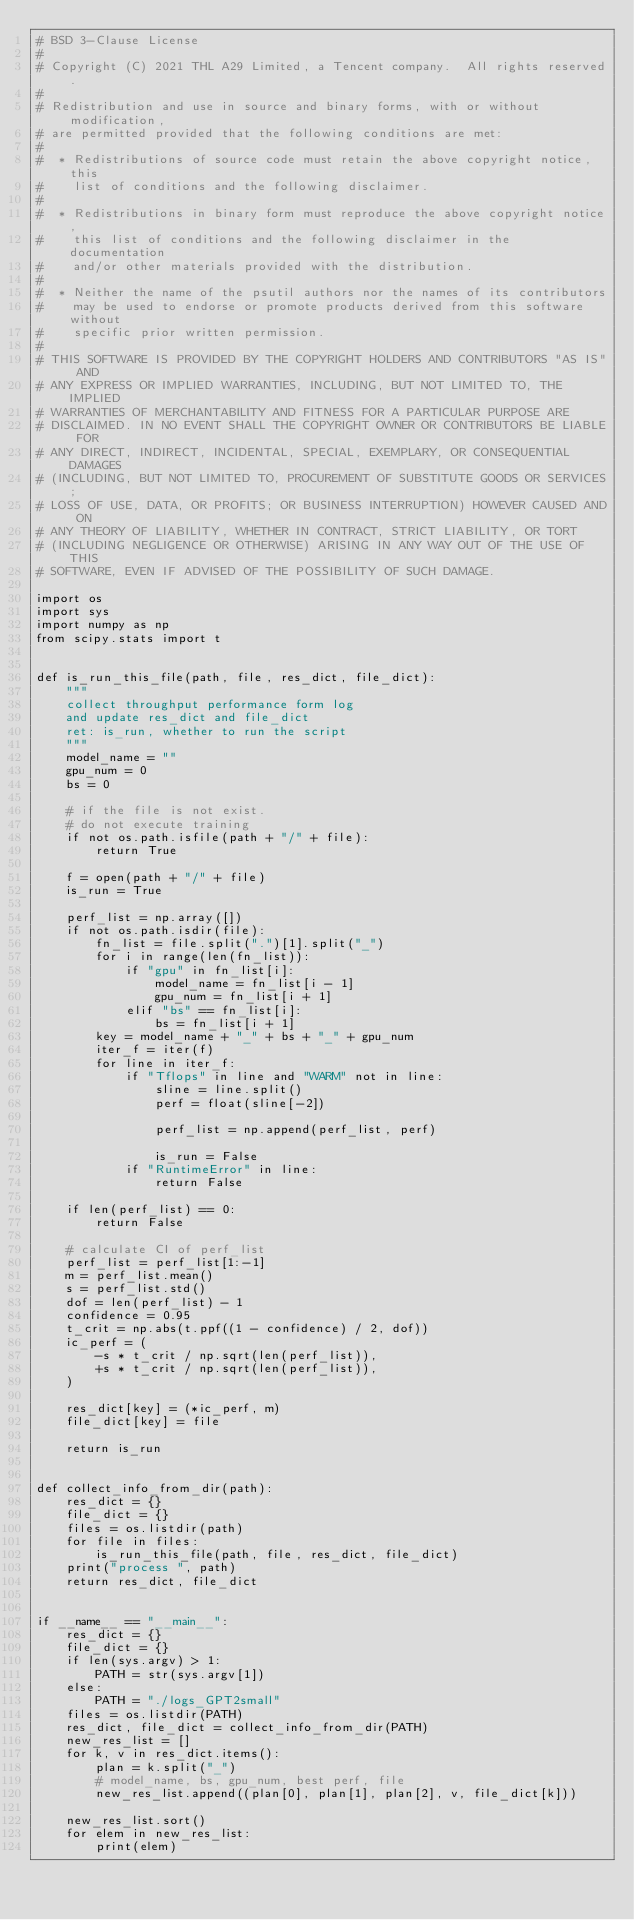Convert code to text. <code><loc_0><loc_0><loc_500><loc_500><_Python_># BSD 3-Clause License
#
# Copyright (C) 2021 THL A29 Limited, a Tencent company.  All rights reserved.
#
# Redistribution and use in source and binary forms, with or without modification,
# are permitted provided that the following conditions are met:
#
#  * Redistributions of source code must retain the above copyright notice, this
#    list of conditions and the following disclaimer.
#
#  * Redistributions in binary form must reproduce the above copyright notice,
#    this list of conditions and the following disclaimer in the documentation
#    and/or other materials provided with the distribution.
#
#  * Neither the name of the psutil authors nor the names of its contributors
#    may be used to endorse or promote products derived from this software without
#    specific prior written permission.
#
# THIS SOFTWARE IS PROVIDED BY THE COPYRIGHT HOLDERS AND CONTRIBUTORS "AS IS" AND
# ANY EXPRESS OR IMPLIED WARRANTIES, INCLUDING, BUT NOT LIMITED TO, THE IMPLIED
# WARRANTIES OF MERCHANTABILITY AND FITNESS FOR A PARTICULAR PURPOSE ARE
# DISCLAIMED. IN NO EVENT SHALL THE COPYRIGHT OWNER OR CONTRIBUTORS BE LIABLE FOR
# ANY DIRECT, INDIRECT, INCIDENTAL, SPECIAL, EXEMPLARY, OR CONSEQUENTIAL DAMAGES
# (INCLUDING, BUT NOT LIMITED TO, PROCUREMENT OF SUBSTITUTE GOODS OR SERVICES;
# LOSS OF USE, DATA, OR PROFITS; OR BUSINESS INTERRUPTION) HOWEVER CAUSED AND ON
# ANY THEORY OF LIABILITY, WHETHER IN CONTRACT, STRICT LIABILITY, OR TORT
# (INCLUDING NEGLIGENCE OR OTHERWISE) ARISING IN ANY WAY OUT OF THE USE OF THIS
# SOFTWARE, EVEN IF ADVISED OF THE POSSIBILITY OF SUCH DAMAGE.

import os
import sys
import numpy as np
from scipy.stats import t


def is_run_this_file(path, file, res_dict, file_dict):
    """
    collect throughput performance form log
    and update res_dict and file_dict
    ret: is_run, whether to run the script
    """
    model_name = ""
    gpu_num = 0
    bs = 0

    # if the file is not exist.
    # do not execute training
    if not os.path.isfile(path + "/" + file):
        return True

    f = open(path + "/" + file)
    is_run = True

    perf_list = np.array([])
    if not os.path.isdir(file):
        fn_list = file.split(".")[1].split("_")
        for i in range(len(fn_list)):
            if "gpu" in fn_list[i]:
                model_name = fn_list[i - 1]
                gpu_num = fn_list[i + 1]
            elif "bs" == fn_list[i]:
                bs = fn_list[i + 1]
        key = model_name + "_" + bs + "_" + gpu_num
        iter_f = iter(f)
        for line in iter_f:
            if "Tflops" in line and "WARM" not in line:
                sline = line.split()
                perf = float(sline[-2])

                perf_list = np.append(perf_list, perf)

                is_run = False
            if "RuntimeError" in line:
                return False

    if len(perf_list) == 0:
        return False

    # calculate CI of perf_list
    perf_list = perf_list[1:-1]
    m = perf_list.mean()
    s = perf_list.std()
    dof = len(perf_list) - 1
    confidence = 0.95
    t_crit = np.abs(t.ppf((1 - confidence) / 2, dof))
    ic_perf = (
        -s * t_crit / np.sqrt(len(perf_list)),
        +s * t_crit / np.sqrt(len(perf_list)),
    )

    res_dict[key] = (*ic_perf, m)
    file_dict[key] = file

    return is_run


def collect_info_from_dir(path):
    res_dict = {}
    file_dict = {}
    files = os.listdir(path)
    for file in files:
        is_run_this_file(path, file, res_dict, file_dict)
    print("process ", path)
    return res_dict, file_dict


if __name__ == "__main__":
    res_dict = {}
    file_dict = {}
    if len(sys.argv) > 1:
        PATH = str(sys.argv[1])
    else:
        PATH = "./logs_GPT2small"
    files = os.listdir(PATH)
    res_dict, file_dict = collect_info_from_dir(PATH)
    new_res_list = []
    for k, v in res_dict.items():
        plan = k.split("_")
        # model_name, bs, gpu_num, best perf, file
        new_res_list.append((plan[0], plan[1], plan[2], v, file_dict[k]))

    new_res_list.sort()
    for elem in new_res_list:
        print(elem)
</code> 